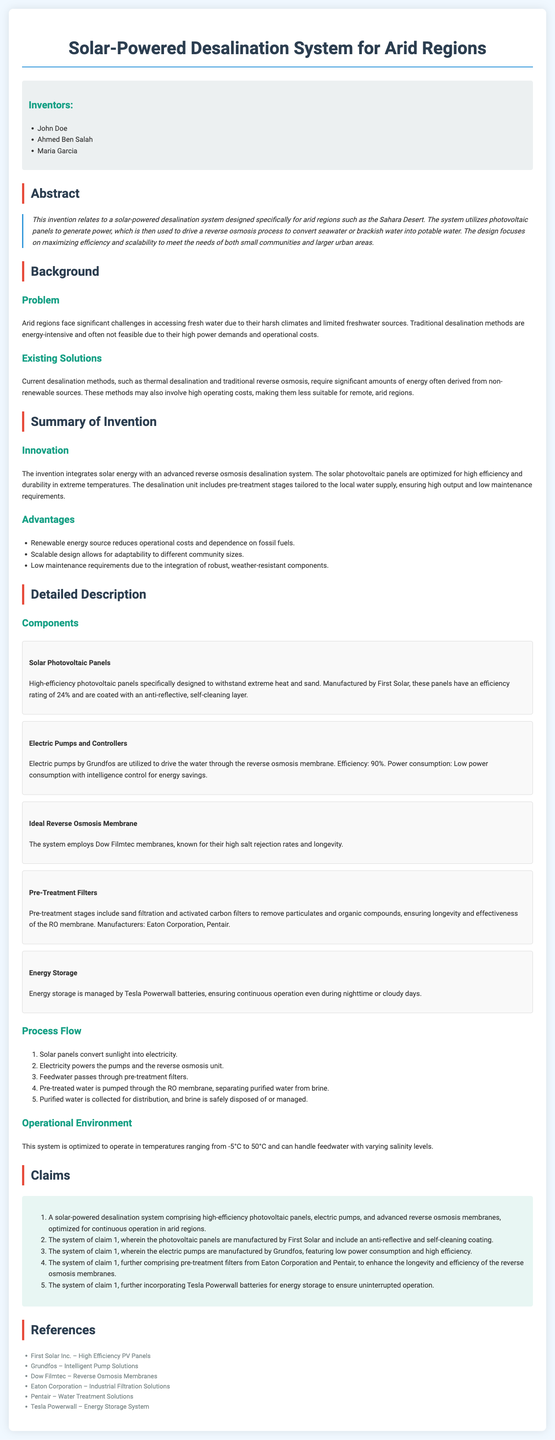What is the title of the patent application? The title is found at the top of the document, summarizing the main concept.
Answer: Solar-Powered Desalination System for Arid Regions Who are the inventors of the system? The inventors are listed in a section dedicated to them in the document.
Answer: John Doe, Ahmed Ben Salah, Maria Garcia What is the efficiency rating of the photovoltaic panels? The efficiency is mentioned in the detailed description of the components.
Answer: 24% What batteries are used for energy storage in the system? The use of specific batteries for energy storage is detailed in the components section.
Answer: Tesla Powerwall What is the operational temperature range of the system? The operational environment section specifies the ideal temperature limits.
Answer: -5°C to 50°C What are the names of two manufacturers of pre-treatment filters? The document lists the manufacturers of pre-treatment filters under the component description.
Answer: Eaton Corporation, Pentair What process involves separating purified water from brine? The specific process is explained in the description of how the system operates.
Answer: Reverse osmosis What energy source does the system rely on to operate? The abstract highlights the main energy source utilized by the system.
Answer: Solar energy How many claims are made regarding the system? The claims section includes a numerical list of claims related to the invention.
Answer: 5 